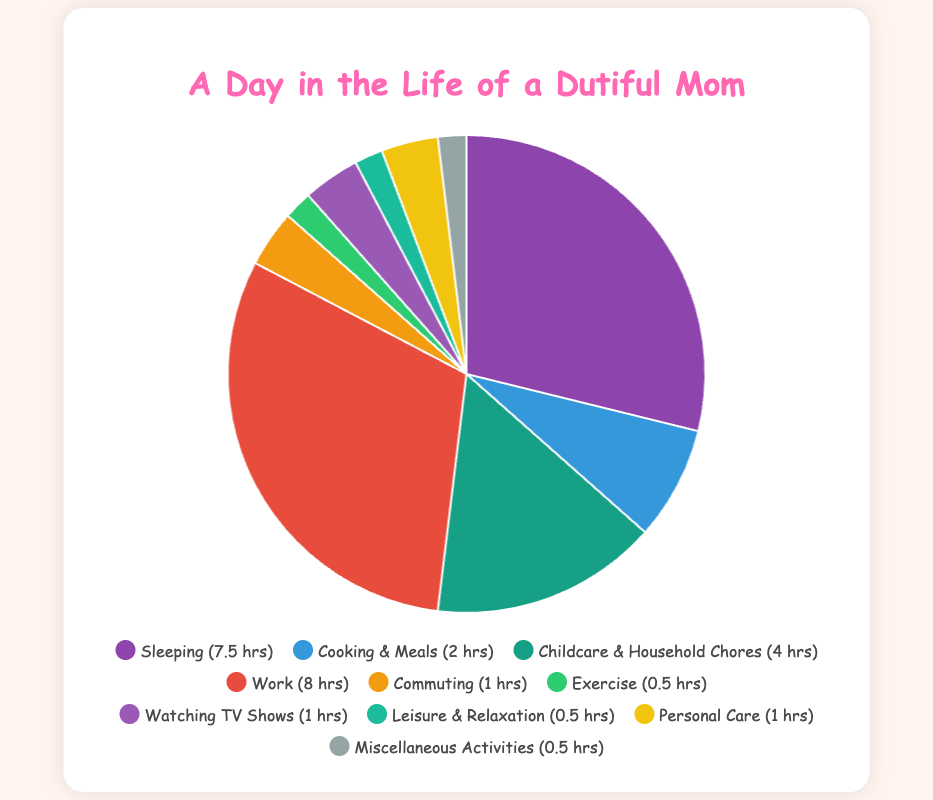Which activity takes up the most amount of time in a day? According to the pie chart, 'Work' consumes the most time at 8 hours.
Answer: Work Which activities take up equal amounts of time? From the visual, 'Watching TV Shows', 'Personal Care', and 'Commuting' each consume 1 hour. Additionally, 'Exercise', 'Leisure & Relaxation', and 'Miscellaneous Activities' each take 0.5 hours.
Answer: Watching TV Shows, Personal Care, Commuting, Exercise, Leisure & Relaxation, Miscellaneous Activities How many hours in total are spent on 'Sleeping' and 'Childcare & Household Chores'? Add the hours spent on 'Sleeping' (7.5) and 'Childcare & Household Chores' (4): 7.5 + 4 = 11.5
Answer: 11.5 Which activity is represented by the color purple? The color purple on the chart represents 'Watching TV Shows'.
Answer: Watching TV Shows How many more hours are spent on 'Work' compared to 'Commuting'? Subtract the hours spent on 'Commuting' (1) from the hours spent on 'Work' (8): 8 - 1 = 7
Answer: 7 By looking at the chart, which segment has the smallest portion? The smallest segment is 'Exercise', 'Leisure & Relaxation', and 'Miscellaneous Activities', each taking up 0.5 hours.
Answer: Exercise, Leisure & Relaxation, Miscellaneous Activities Summing up all activities, how many total hours are spent in a day? Add all the hours from each activity: 7.5 + 2 + 4 + 8 + 1 + 0.5 + 1 + 0.5 + 1 + 0.5 = 26
Answer: 26 Among the listed activities, which two together make up exactly 3 hours? The activities 'Cooking & Meals' (2 hours) and 'Commuting' (1 hour) add up to 3 hours.
Answer: Cooking & Meals, Commuting Which activity has more hours allocated: 'Childcare & Household Chores' or 'Sleeping'? Compare 'Childcare & Household Chores' (4 hours) with 'Sleeping' (7.5 hours). 'Sleeping' has more time allocated.
Answer: Sleeping 